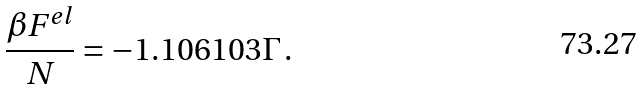Convert formula to latex. <formula><loc_0><loc_0><loc_500><loc_500>\frac { \beta F ^ { e l } } { N } = - 1 . 1 0 6 1 0 3 \Gamma \, .</formula> 